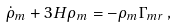Convert formula to latex. <formula><loc_0><loc_0><loc_500><loc_500>\dot { \rho } _ { m } + 3 H \rho _ { m } = - \rho _ { m } \Gamma _ { m r } \, ,</formula> 